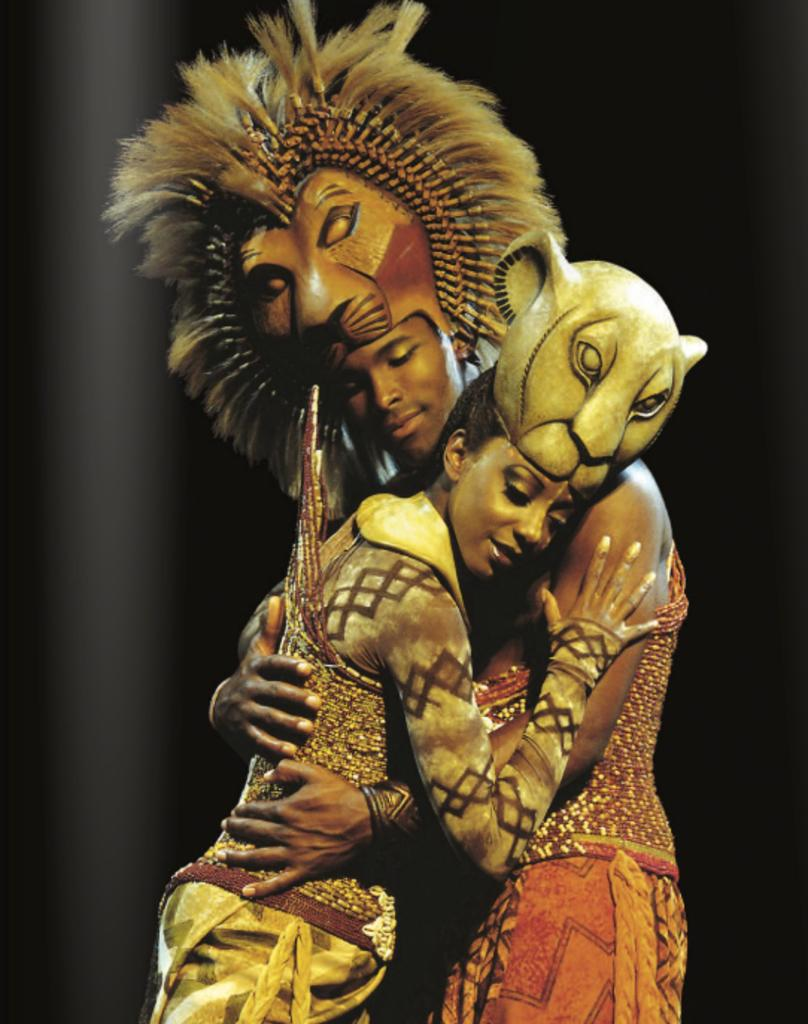What are the persons in the foreground of the image wearing? The persons in the foreground of the image are wearing lion costumes. What are the persons in the lion costumes doing? The persons are hugging each other. What can be observed about the background of the image? The background of the image is dark. What type of curtain can be seen in the image? There is no curtain present in the image. What is the motion of the brick in the image? There is no brick present in the image, so its motion cannot be determined. 